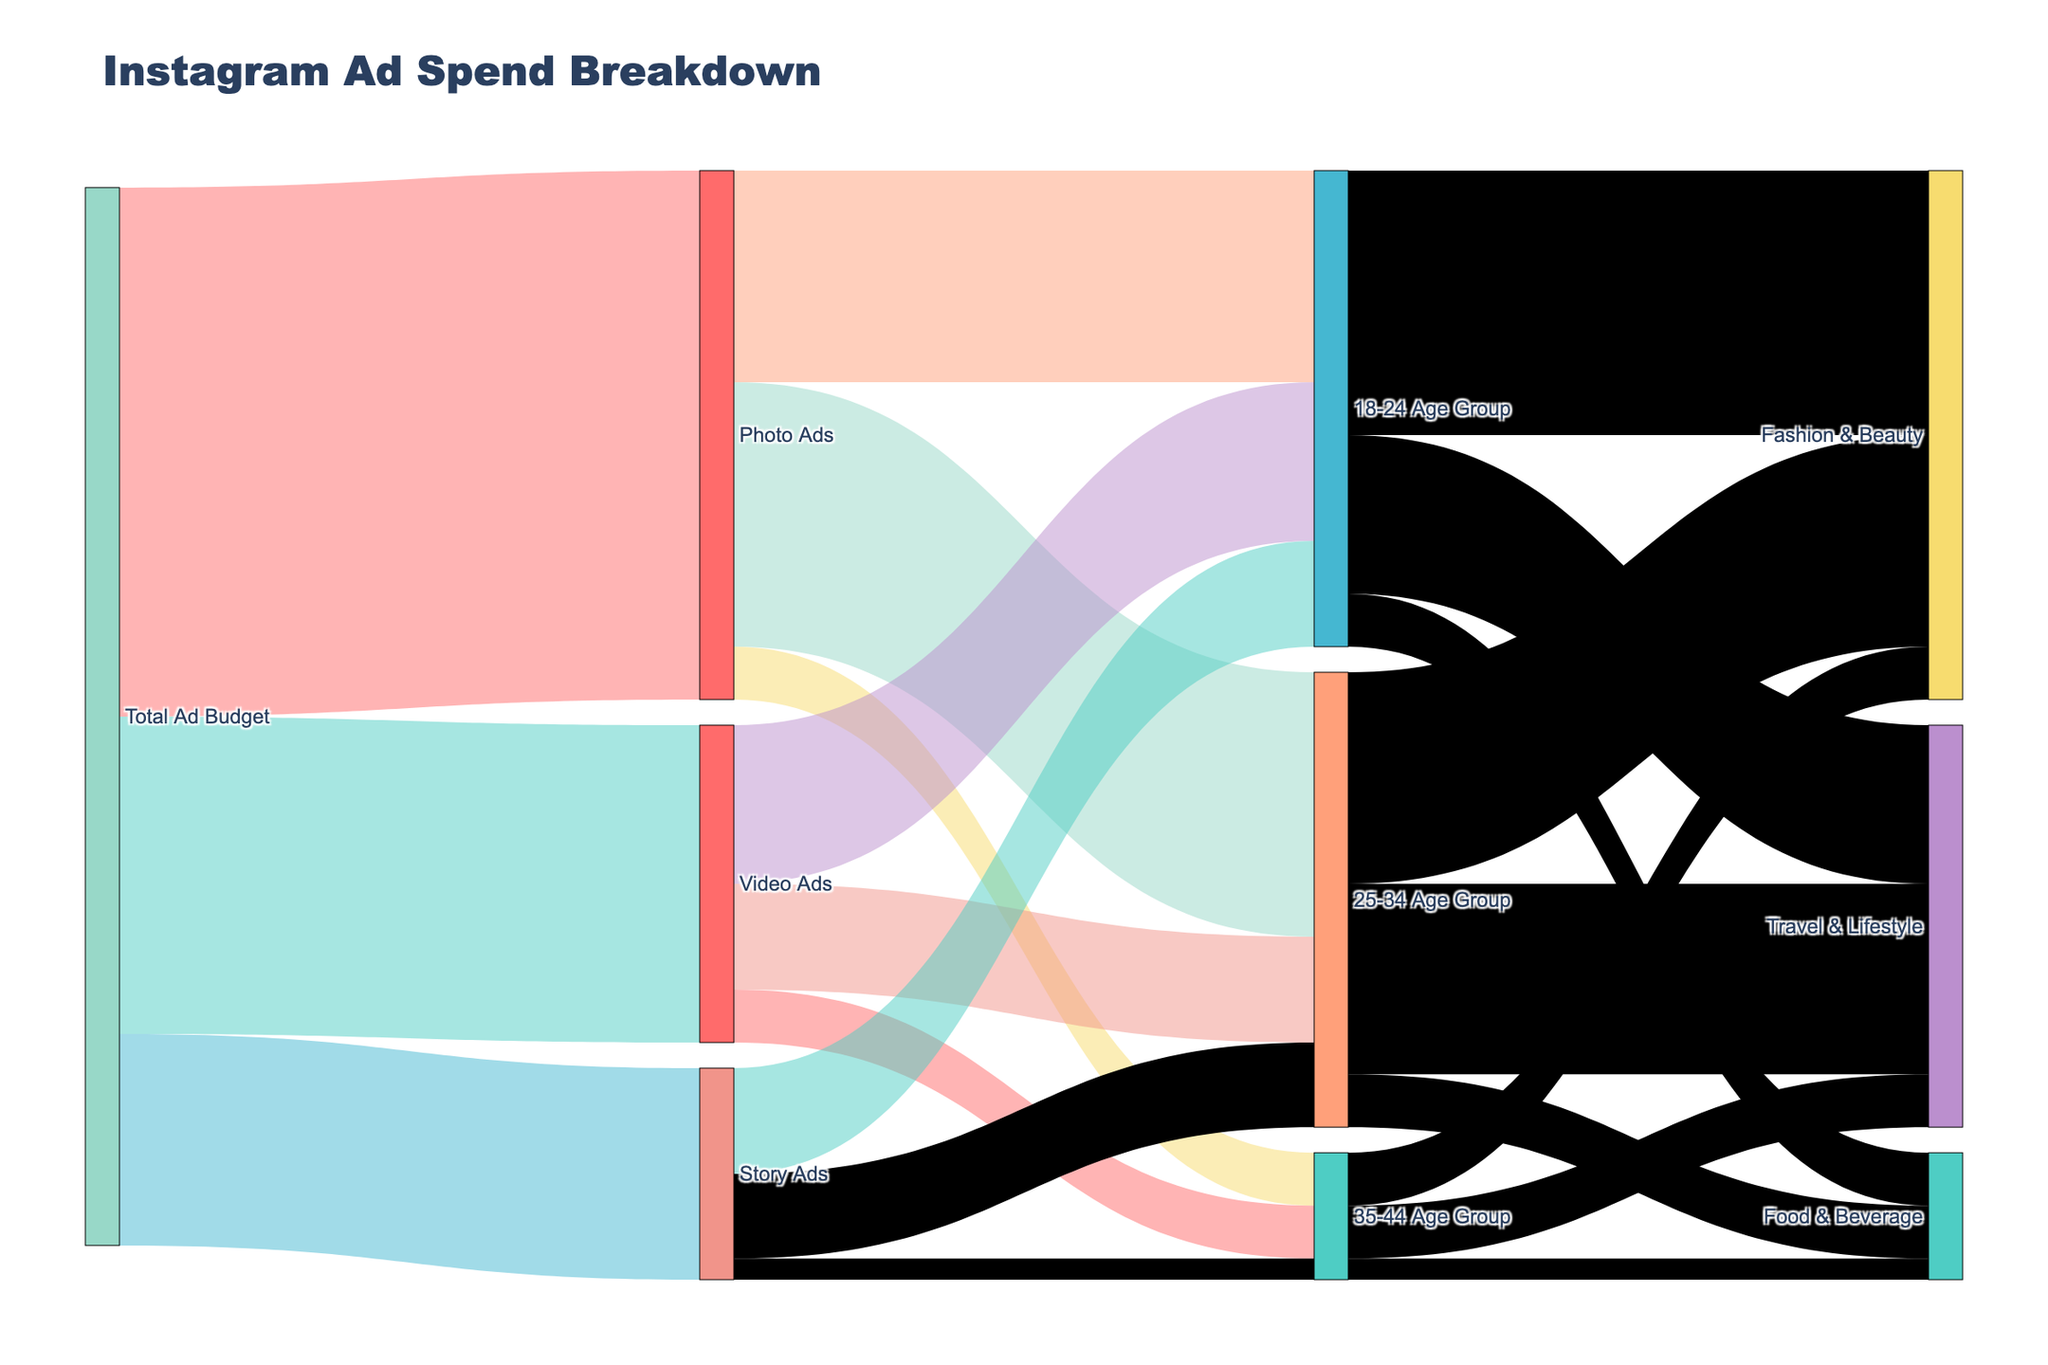What's the total ad budget allocated to Video Ads? Identify the link starting from "Total Ad Budget" and ending at "Video Ads". The value on this link is 300,000.
Answer: 300,000 Which target demographic received the least budget for Photo Ads? Look at the links from "Photo Ads" to different age groups (18-24, 25-34, 35-44). The smallest value here is 50,000 allocated to the 35-44 age group.
Answer: 35-44 Age Group What's the combined budget allocated to the Travel & Lifestyle category across all age groups? Sum the values from 18-24 (150,000), 25-34 (180,000), and 35-44 (50,000). The total is 150,000 + 180,000 + 50,000 = 380,000.
Answer: 380,000 Which ad type received the highest budget from the Total Ad Budget? Compare the values of links starting from "Total Ad Budget" to "Photo Ads" (500,000), "Video Ads" (300,000), and "Story Ads" (200,000). The highest value is 500,000 for Photo Ads.
Answer: Photo Ads How much of the 18-24 Age Group budget was allocated to Fashion & Beauty and Food & Beverage? Locate the values from the 18-24 Age Group to "Fashion & Beauty" (250,000) and "Food & Beverage" (50,000). The total is 250,000 + 50,000 = 300,000.
Answer: 300,000 Which category received more budget from the 25-34 Age Group, Fashion & Beauty, or Travel & Lifestyle? Compare values from 25-34 Age Group to "Fashion & Beauty" (200,000) and "Travel & Lifestyle" (180,000). Fashion & Beauty received more with 200,000.
Answer: Fashion & Beauty What proportion of the 35-44 Age Group budget went to Food & Beverage? First, calculate the total budget for the 35-44 Age Group: 50,000 (Photo Ads) + 50,000 (Video Ads) + 20,000 (Story Ads) = 120,000. The budget for Food & Beverage is 20,000. Therefore, the proportion is 20,000 / 120,000 = 1/6 or approximately 16.67%.
Answer: 16.67% Which ad type has the smallest age group budget portion for the 25-34 Age Group? Compare the values from "25-34 Age Group" to "Photo Ads" (250,000), "Video Ads" (100,000), and "Story Ads" (80,000). The smallest value is 80,000 for Story Ads.
Answer: Story Ads How does the budget for 18-24 Age Group Story Ads compare to 25-34 Age Group Story Ads? Compare the values allocated from "Story Ads" to "18-24 Age Group" (100,000) and "25-34 Age Group" (80,000). The 18-24 Age Group has 20,000 more.
Answer: 18-24 Age Group has 20,000 more What is the largest single budget allocation from Total Ad Budget to a promotion type? Identify the largest value among the links starting from "Total Ad Budget": 500,000 (Photo Ads), 300,000 (Video Ads), and 200,000 (Story Ads). The largest value is 500,000 for Photo Ads.
Answer: 500,000 to Photo Ads 